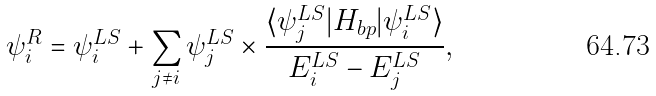<formula> <loc_0><loc_0><loc_500><loc_500>\psi _ { i } ^ { R } = \psi _ { i } ^ { L S } + \sum _ { j \neq i } \psi _ { j } ^ { L S } \times \frac { \langle \psi _ { j } ^ { L S } | H _ { b p } | \psi _ { i } ^ { L S } \rangle } { E _ { i } ^ { L S } - E _ { j } ^ { L S } } ,</formula> 